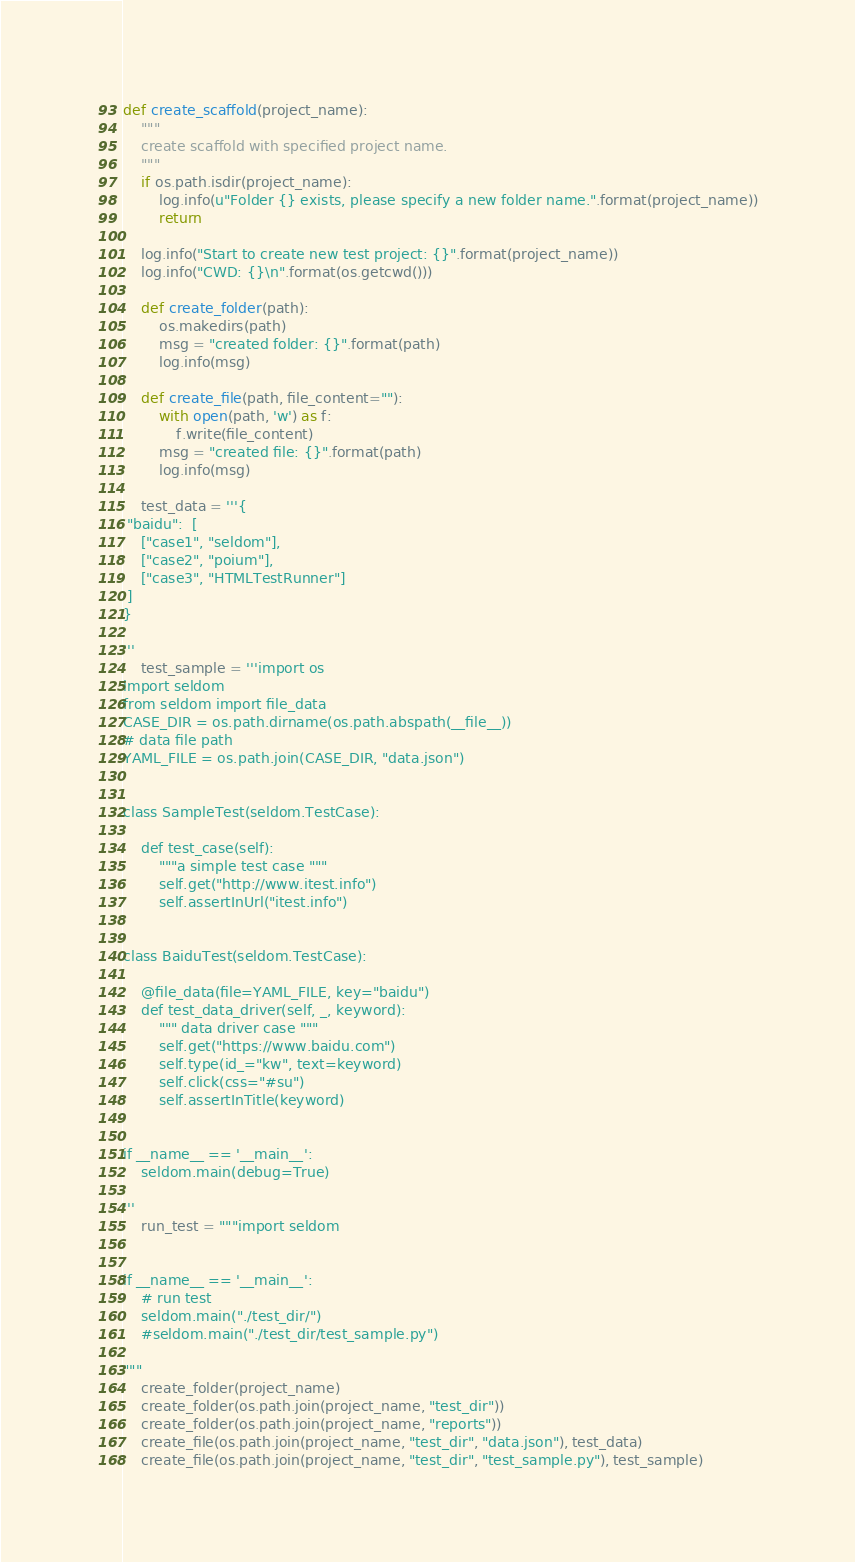Convert code to text. <code><loc_0><loc_0><loc_500><loc_500><_Python_>

def create_scaffold(project_name):
    """
    create scaffold with specified project name.
    """
    if os.path.isdir(project_name):
        log.info(u"Folder {} exists, please specify a new folder name.".format(project_name))
        return

    log.info("Start to create new test project: {}".format(project_name))
    log.info("CWD: {}\n".format(os.getcwd()))

    def create_folder(path):
        os.makedirs(path)
        msg = "created folder: {}".format(path)
        log.info(msg)

    def create_file(path, file_content=""):
        with open(path, 'w') as f:
            f.write(file_content)
        msg = "created file: {}".format(path)
        log.info(msg)

    test_data = '''{
 "baidu":  [
    ["case1", "seldom"],
    ["case2", "poium"],
    ["case3", "HTMLTestRunner"]
 ]
}

'''
    test_sample = '''import os
import seldom
from seldom import file_data
CASE_DIR = os.path.dirname(os.path.abspath(__file__))
# data file path
YAML_FILE = os.path.join(CASE_DIR, "data.json")


class SampleTest(seldom.TestCase):

    def test_case(self):
        """a simple test case """
        self.get("http://www.itest.info")
        self.assertInUrl("itest.info")


class BaiduTest(seldom.TestCase):

    @file_data(file=YAML_FILE, key="baidu")
    def test_data_driver(self, _, keyword):
        """ data driver case """
        self.get("https://www.baidu.com")
        self.type(id_="kw", text=keyword)
        self.click(css="#su")
        self.assertInTitle(keyword)


if __name__ == '__main__':
    seldom.main(debug=True)

'''
    run_test = """import seldom


if __name__ == '__main__':
    # run test
    seldom.main("./test_dir/")
    #seldom.main("./test_dir/test_sample.py")

"""
    create_folder(project_name)
    create_folder(os.path.join(project_name, "test_dir"))
    create_folder(os.path.join(project_name, "reports"))
    create_file(os.path.join(project_name, "test_dir", "data.json"), test_data)
    create_file(os.path.join(project_name, "test_dir", "test_sample.py"), test_sample)</code> 